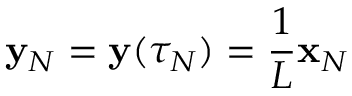Convert formula to latex. <formula><loc_0><loc_0><loc_500><loc_500>{ \mathbf y } _ { N } = { \mathbf y } ( \tau _ { N } ) = \frac { 1 } { L } { \mathbf x } _ { N }</formula> 